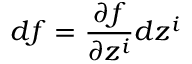<formula> <loc_0><loc_0><loc_500><loc_500>d f = \frac { \partial f } { \partial z ^ { i } } d z ^ { i }</formula> 